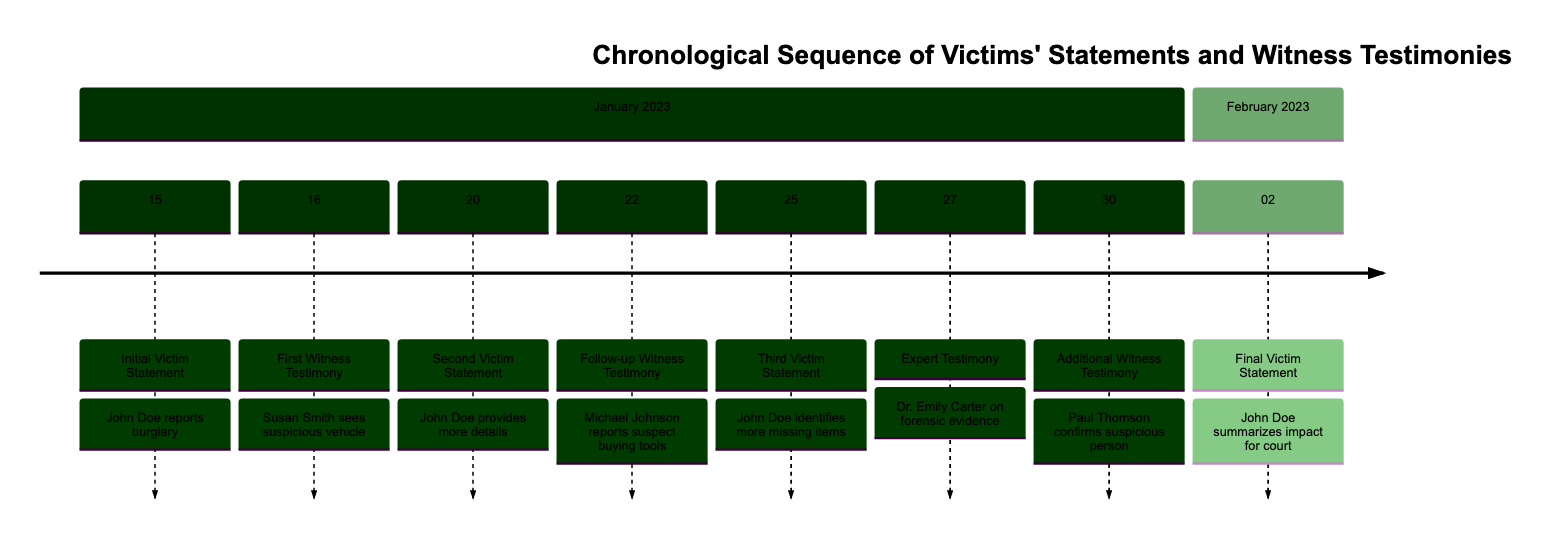What is the date of the Initial Victim Statement? The timeline indicates that the Initial Victim Statement occurred on January 15, 2023, as seen in the first entry of the diagram.
Answer: January 15 Who provided the First Witness Testimony? According to the diagram, the First Witness Testimony was given by neighbor Susan Smith, as stated in the second entry.
Answer: Susan Smith How many Victim Statements are recorded in the timeline? By counting the Victim Statements listed, there are a total of four: Initial, Second, Third, and Final, which can be separately identified in the diagram.
Answer: 4 What relationship can be seen between John Doe's statements and witness testimonies? The timeline shows that after John Doe's statements, there are corresponding witness testimonies that provide supporting details, indicating a sequential flow of information in the investigation.
Answer: Sequential flow What analysis did Dr. Emily Carter provide? Dr. Emily Carter provided expert testimony on fingerprints and DNA evidence collected from the crime scene, as detailed in the entry dated January 27, 2023.
Answer: Forensic evidence When did John Doe summarize the impact of the burglary? The Final Victim Statement summarizing the impact of the burglary occurred on February 2, 2023, as the last event in the timeline.
Answer: February 2 Which witness confirmed seeing a suspicious person before the burglary? The Additional Witness Testimony from delivery driver Paul Thomson confirms seeing a suspicious person near the crime location shortly before the burglary, as noted in the timeline entry.
Answer: Paul Thomson What event took place on January 30? The Additional Witness Testimony, where Paul Thomson confirmed seeing a suspicious person, took place on January 30, 2023, according to the timeline.
Answer: Additional Witness Testimony What was the focus of John Doe's Third Victim Statement? John Doe's Third Victim Statement focused on identifying additional items missing after a more thorough check of his property, which is explicitly stated in the entry dated January 25, 2023.
Answer: Identifying more missing items 